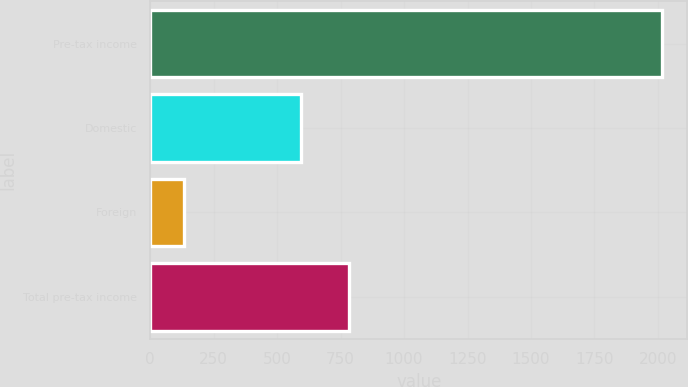Convert chart. <chart><loc_0><loc_0><loc_500><loc_500><bar_chart><fcel>Pre-tax income<fcel>Domestic<fcel>Foreign<fcel>Total pre-tax income<nl><fcel>2015<fcel>593.5<fcel>132.5<fcel>781.75<nl></chart> 